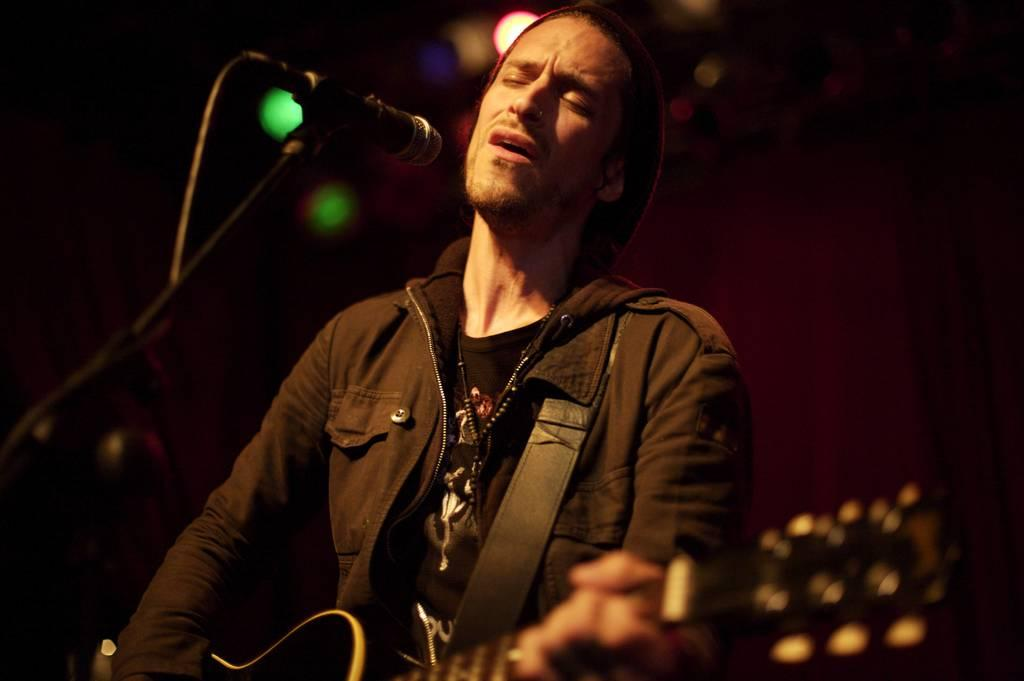What is the man in the image doing? The man is in front of a mic and holding a guitar, which suggests he might be performing or about to perform. What is the man wearing in the image? The man is wearing a black jacket. What can be seen behind the man in the image? There are lights visible in the background of the image. What type of furniture is visible in the image? There is no furniture visible in the image. What record is the man playing on the guitar in the image? The image does not show the man playing a specific record on the guitar; it only shows him holding the guitar. 